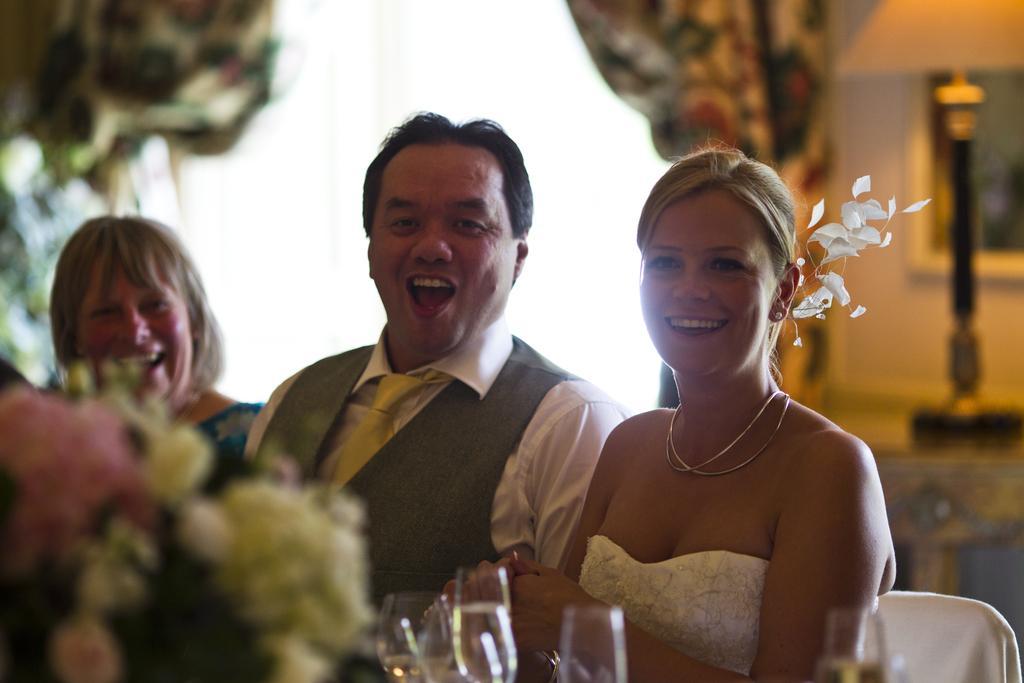Can you describe this image briefly? As we can see a man is sitting in between two women. The right side women wore white dress and neck chain. The left side women having short hair. In front of these people the wine glasses are kept. 